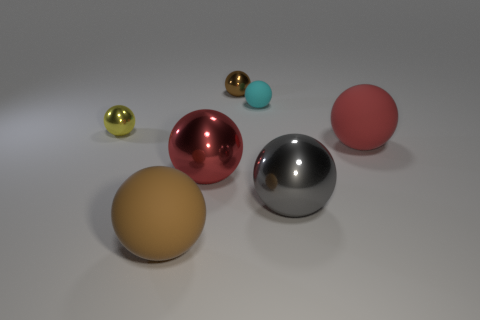What number of other things are the same size as the cyan sphere?
Offer a very short reply. 2. The tiny rubber object has what color?
Your answer should be very brief. Cyan. Do the big rubber object right of the tiny brown ball and the big metallic sphere on the left side of the tiny brown sphere have the same color?
Offer a very short reply. Yes. What size is the brown matte thing?
Provide a short and direct response. Large. There is a object to the left of the big brown matte object; how big is it?
Offer a terse response. Small. What is the shape of the metallic thing that is both in front of the yellow metallic thing and behind the big gray metal object?
Provide a succinct answer. Sphere. How many other objects are the same shape as the brown shiny object?
Your answer should be compact. 6. There is a rubber sphere that is the same size as the yellow object; what is its color?
Offer a terse response. Cyan. How many objects are either red spheres or gray shiny cubes?
Provide a succinct answer. 2. There is a small brown metallic ball; are there any rubber things on the right side of it?
Provide a short and direct response. Yes. 